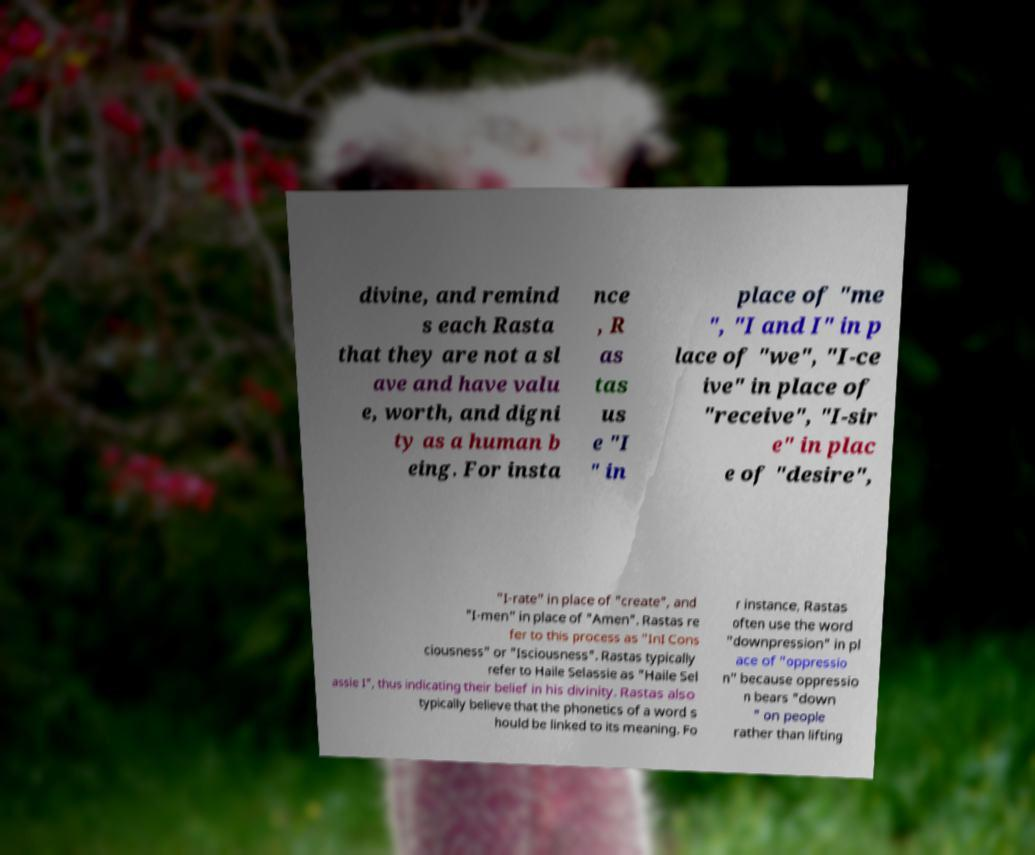Please identify and transcribe the text found in this image. divine, and remind s each Rasta that they are not a sl ave and have valu e, worth, and digni ty as a human b eing. For insta nce , R as tas us e "I " in place of "me ", "I and I" in p lace of "we", "I-ce ive" in place of "receive", "I-sir e" in plac e of "desire", "I-rate" in place of "create", and "I-men" in place of "Amen". Rastas re fer to this process as "InI Cons ciousness" or "Isciousness". Rastas typically refer to Haile Selassie as "Haile Sel assie I", thus indicating their belief in his divinity. Rastas also typically believe that the phonetics of a word s hould be linked to its meaning. Fo r instance, Rastas often use the word "downpression" in pl ace of "oppressio n" because oppressio n bears "down " on people rather than lifting 